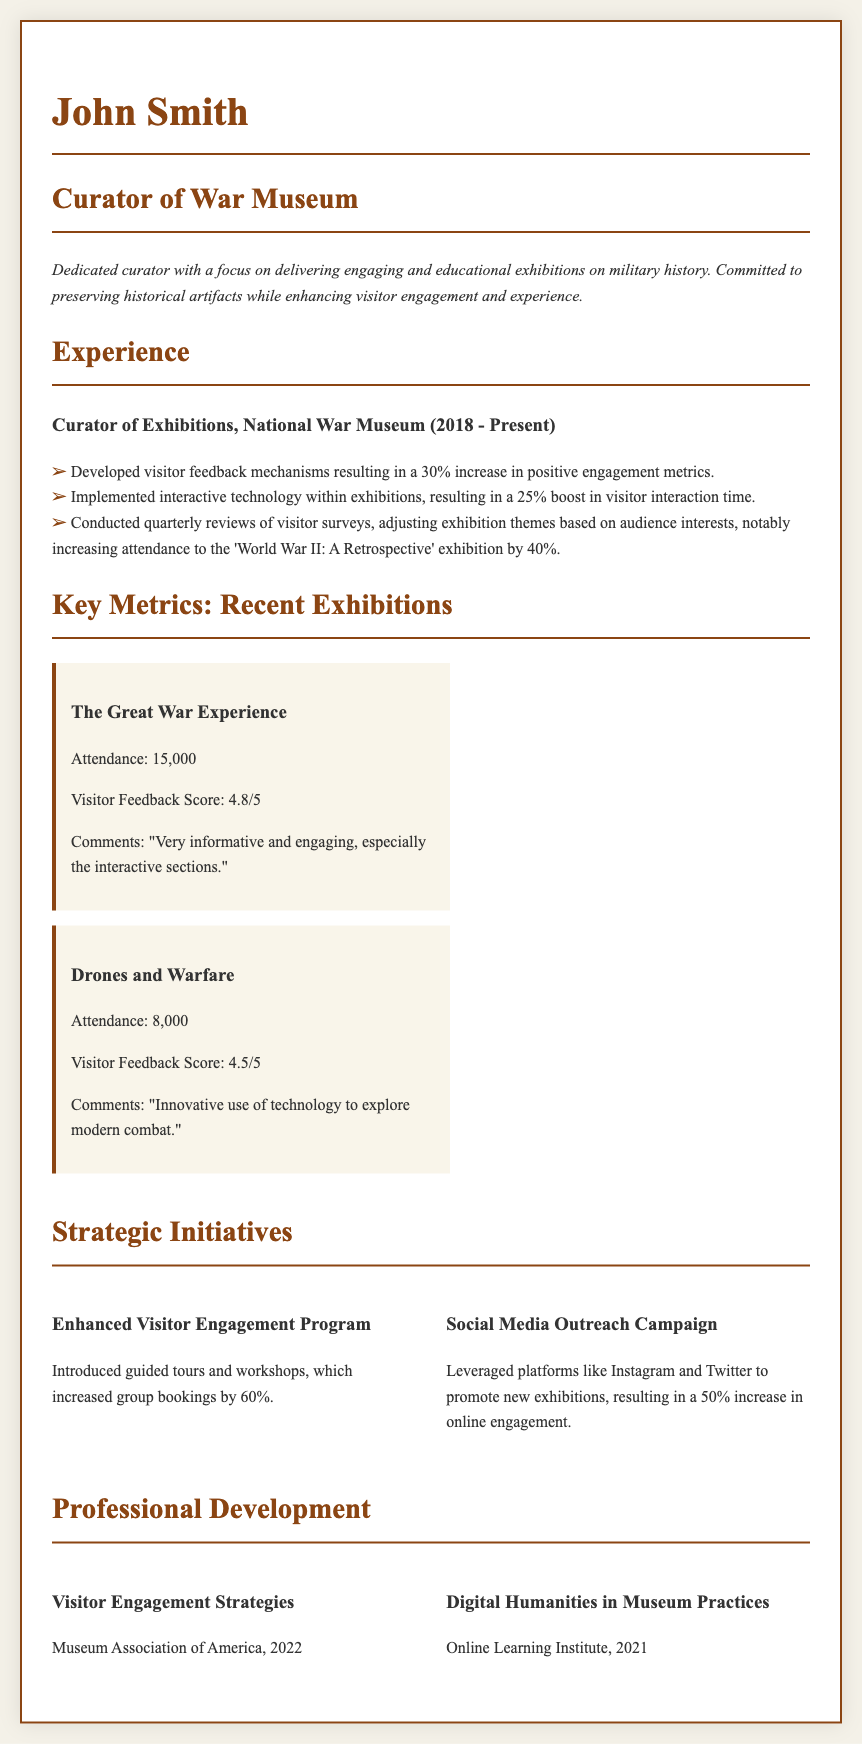What is the visitor feedback score for "The Great War Experience"? The visitor feedback score is specifically noted in the metrics section for this exhibition.
Answer: 4.8/5 What percentage increase in positive engagement metrics resulted from visitor feedback mechanisms? The document states that there was a 30% increase in positive engagement metrics from the feedback mechanisms developed.
Answer: 30% How many attendees did the "Drones and Warfare" exhibition have? The document provides specific attendance figures for each exhibition in the metrics section.
Answer: 8,000 What strategic initiative resulted in a 60% increase in group bookings? The document details various strategic initiatives, and this particular increase is attributed to the Enhanced Visitor Engagement Program.
Answer: Enhanced Visitor Engagement Program Which organization offered the course on Visitor Engagement Strategies? The document lists the organizations associated with each professional development course; this course was offered by the Museum Association of America.
Answer: Museum Association of America What is the main theme of the exhibition that saw a 40% increase in attendance? The document indicates that the adjustment of exhibition themes based on audience interests led to this specific increase during a particular exhibition.
Answer: World War II: A Retrospective What technology implementation resulted in a 25% boost? This refers to the interactive technology implemented within exhibitions, specifically mentioned in the experience section of the document.
Answer: Interactive technology What year was the course on Digital Humanities in Museum Practices completed? The document lists completion years for courses under professional development, and this course was completed in 2021.
Answer: 2021 How many comments were summarized for "Drones and Warfare"? The document provides feedback comments for the exhibitions but does not specify an exact number; one comment is highlighted.
Answer: "Innovative use of technology to explore modern combat." 